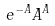<formula> <loc_0><loc_0><loc_500><loc_500>e ^ { - A } A ^ { A }</formula> 